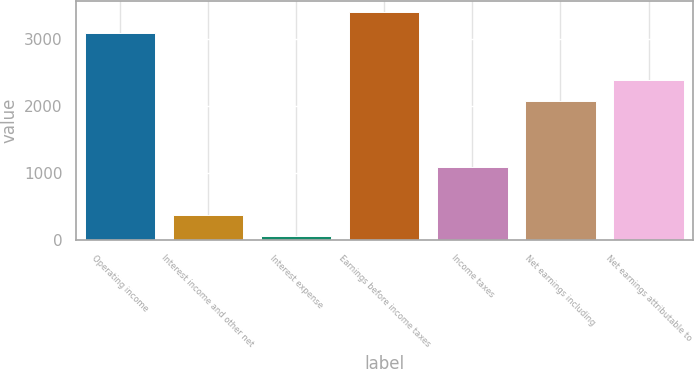Convert chart to OTSL. <chart><loc_0><loc_0><loc_500><loc_500><bar_chart><fcel>Operating income<fcel>Interest income and other net<fcel>Interest expense<fcel>Earnings before income taxes<fcel>Income taxes<fcel>Net earnings including<fcel>Net earnings attributable to<nl><fcel>3081.1<fcel>373.66<fcel>64.1<fcel>3390.66<fcel>1092<fcel>2067.7<fcel>2377.26<nl></chart> 